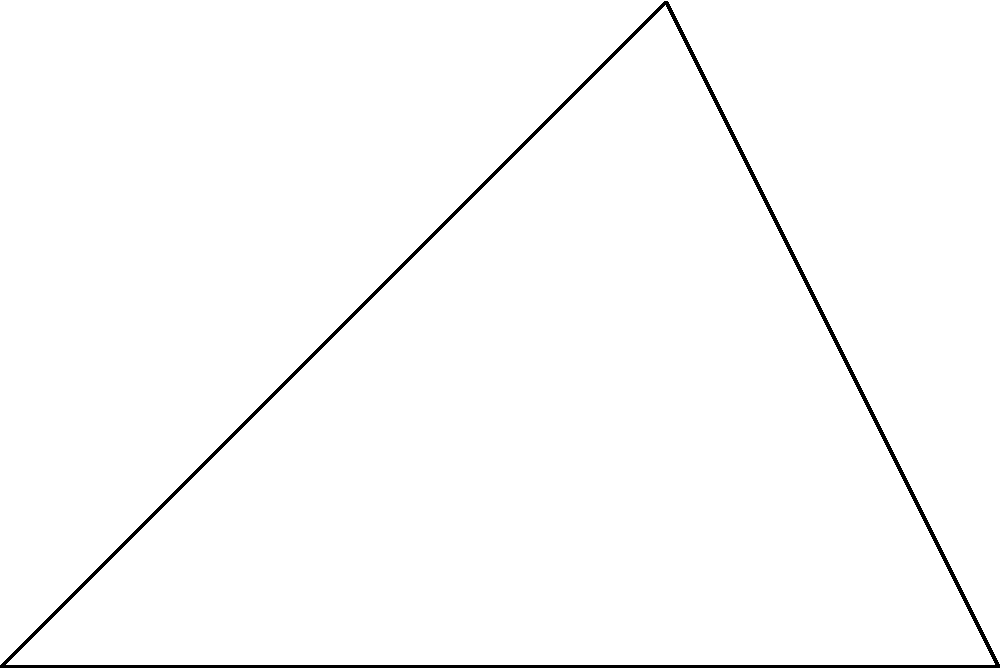As part of your feedback on the advanced prosthetic, you need to calculate the angle of rotation for a specific joint. Given the initial position of the prosthetic joint at point A(3,0) and its final position at point B(2,2) in a 2D coordinate system, calculate the angle of rotation $\theta$ in degrees. Use the arctangent function and coordinate transformations to determine the angle. To calculate the angle of rotation $\theta$, we'll follow these steps:

1) First, we need to find the vector from the origin O to point B. This vector is $\vec{OB} = (2,2)$.

2) We can use the arctangent function to find the angle between this vector and the positive x-axis. However, we need to use atan2 to consider the quadrant:

   $\theta = \text{atan2}(y, x) = \text{atan2}(2, 2)$

3) The atan2 function returns the angle in radians. To convert to degrees, we multiply by $\frac{180}{\pi}$:

   $\theta = \text{atan2}(2, 2) \cdot \frac{180}{\pi} \approx 45°$

4) However, this is not the final answer. We need to consider that the initial position was at A(3,0), not at the origin.

5) To account for this, we need to perform a coordinate transformation. We subtract the coordinates of A from B:

   $B' = B - A = (2,2) - (3,0) = (-1,2)$

6) Now we can use atan2 with these transformed coordinates:

   $\theta = \text{atan2}(2, -1) \cdot \frac{180}{\pi} \approx 116.57°$

This is the angle of rotation from the initial position A to the final position B.
Answer: $116.57°$ 